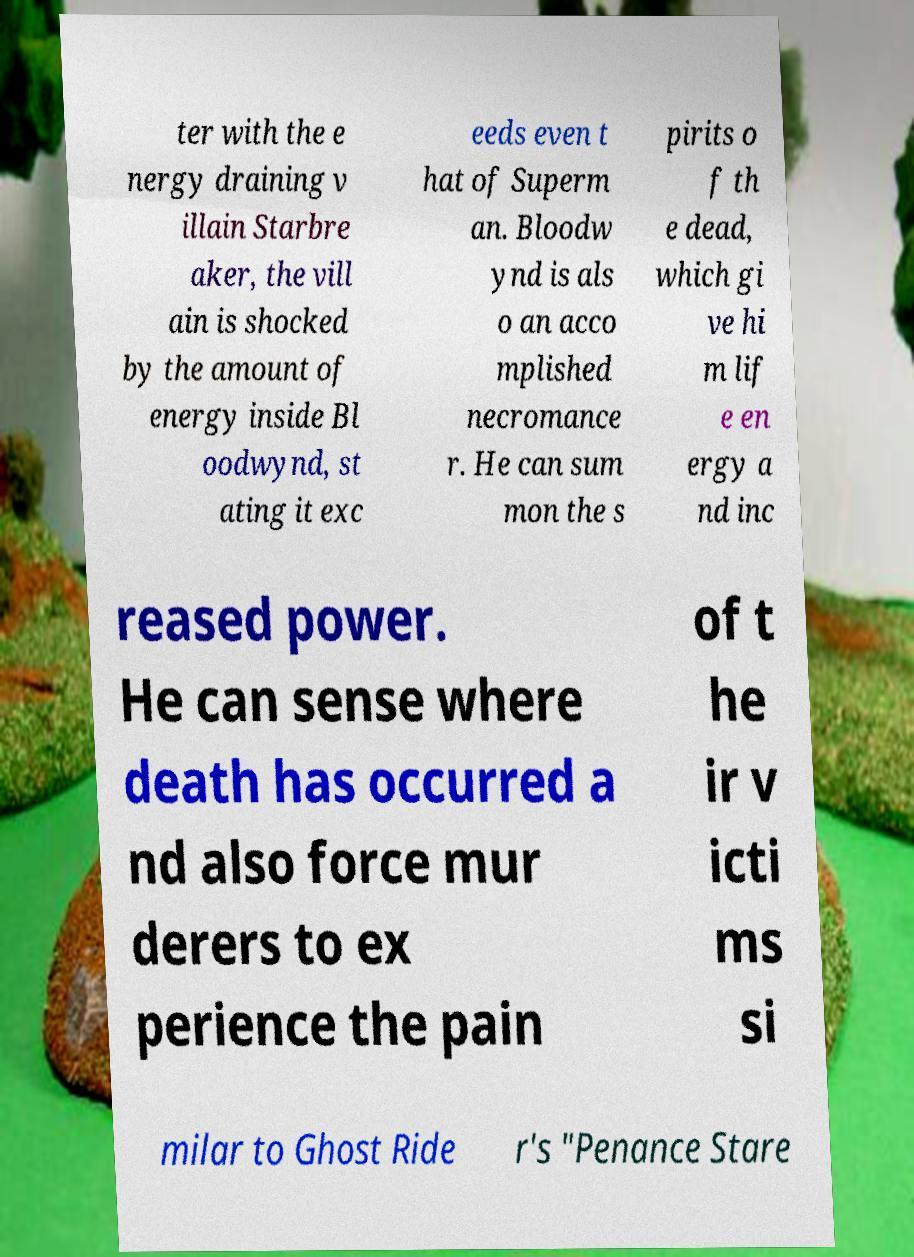Please read and relay the text visible in this image. What does it say? ter with the e nergy draining v illain Starbre aker, the vill ain is shocked by the amount of energy inside Bl oodwynd, st ating it exc eeds even t hat of Superm an. Bloodw ynd is als o an acco mplished necromance r. He can sum mon the s pirits o f th e dead, which gi ve hi m lif e en ergy a nd inc reased power. He can sense where death has occurred a nd also force mur derers to ex perience the pain of t he ir v icti ms si milar to Ghost Ride r's "Penance Stare 